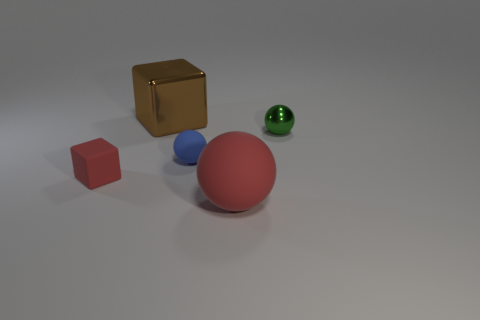How many blue objects are big metal blocks or spheres? There are no blue objects that are big metal blocks or spheres in the image. The only blue object present is a small sphere. 